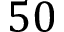<formula> <loc_0><loc_0><loc_500><loc_500>5 0</formula> 